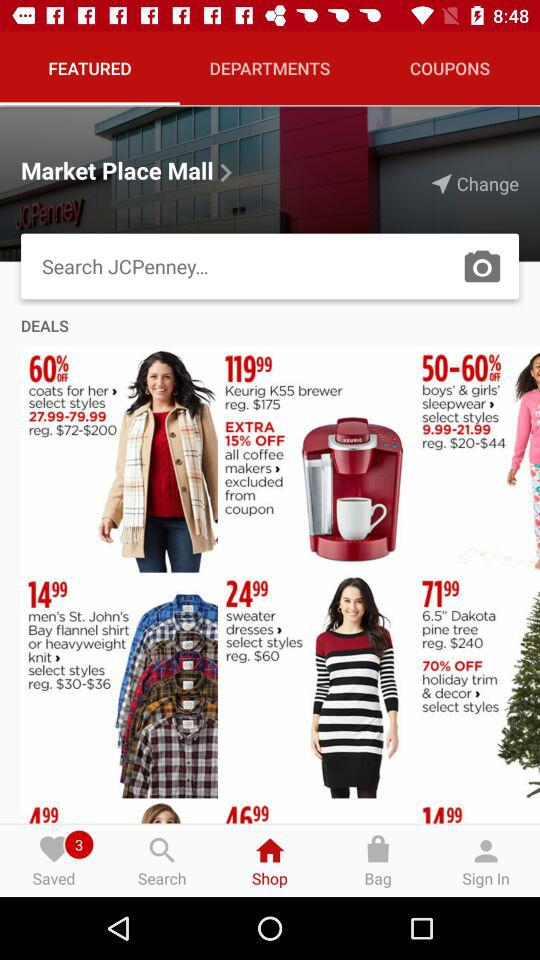How many new saved items are there? There are 3 new saved items. 